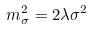<formula> <loc_0><loc_0><loc_500><loc_500>m _ { \sigma } ^ { 2 } = 2 \lambda \sigma ^ { 2 }</formula> 